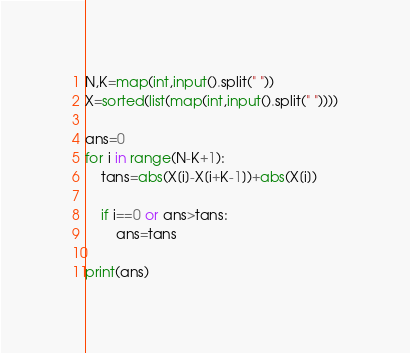<code> <loc_0><loc_0><loc_500><loc_500><_Python_>N,K=map(int,input().split(" "))
X=sorted(list(map(int,input().split(" "))))

ans=0
for i in range(N-K+1):
    tans=abs(X[i]-X[i+K-1])+abs(X[i])

    if i==0 or ans>tans:
        ans=tans
    
print(ans)</code> 